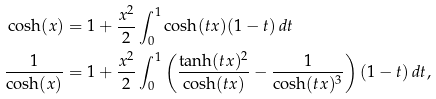<formula> <loc_0><loc_0><loc_500><loc_500>\cosh ( x ) & = 1 + \frac { x ^ { 2 } } { 2 } \int _ { 0 } ^ { 1 } \cosh ( t x ) ( 1 - t ) \, d t \\ \frac { 1 } { \cosh ( x ) } & = 1 + \frac { x ^ { 2 } } { 2 } \int _ { 0 } ^ { 1 } \left ( \frac { \tanh ( t x ) ^ { 2 } } { \cosh ( t x ) } - \frac { 1 } { \cosh ( t x ) ^ { 3 } } \right ) ( 1 - t ) \, d t ,</formula> 